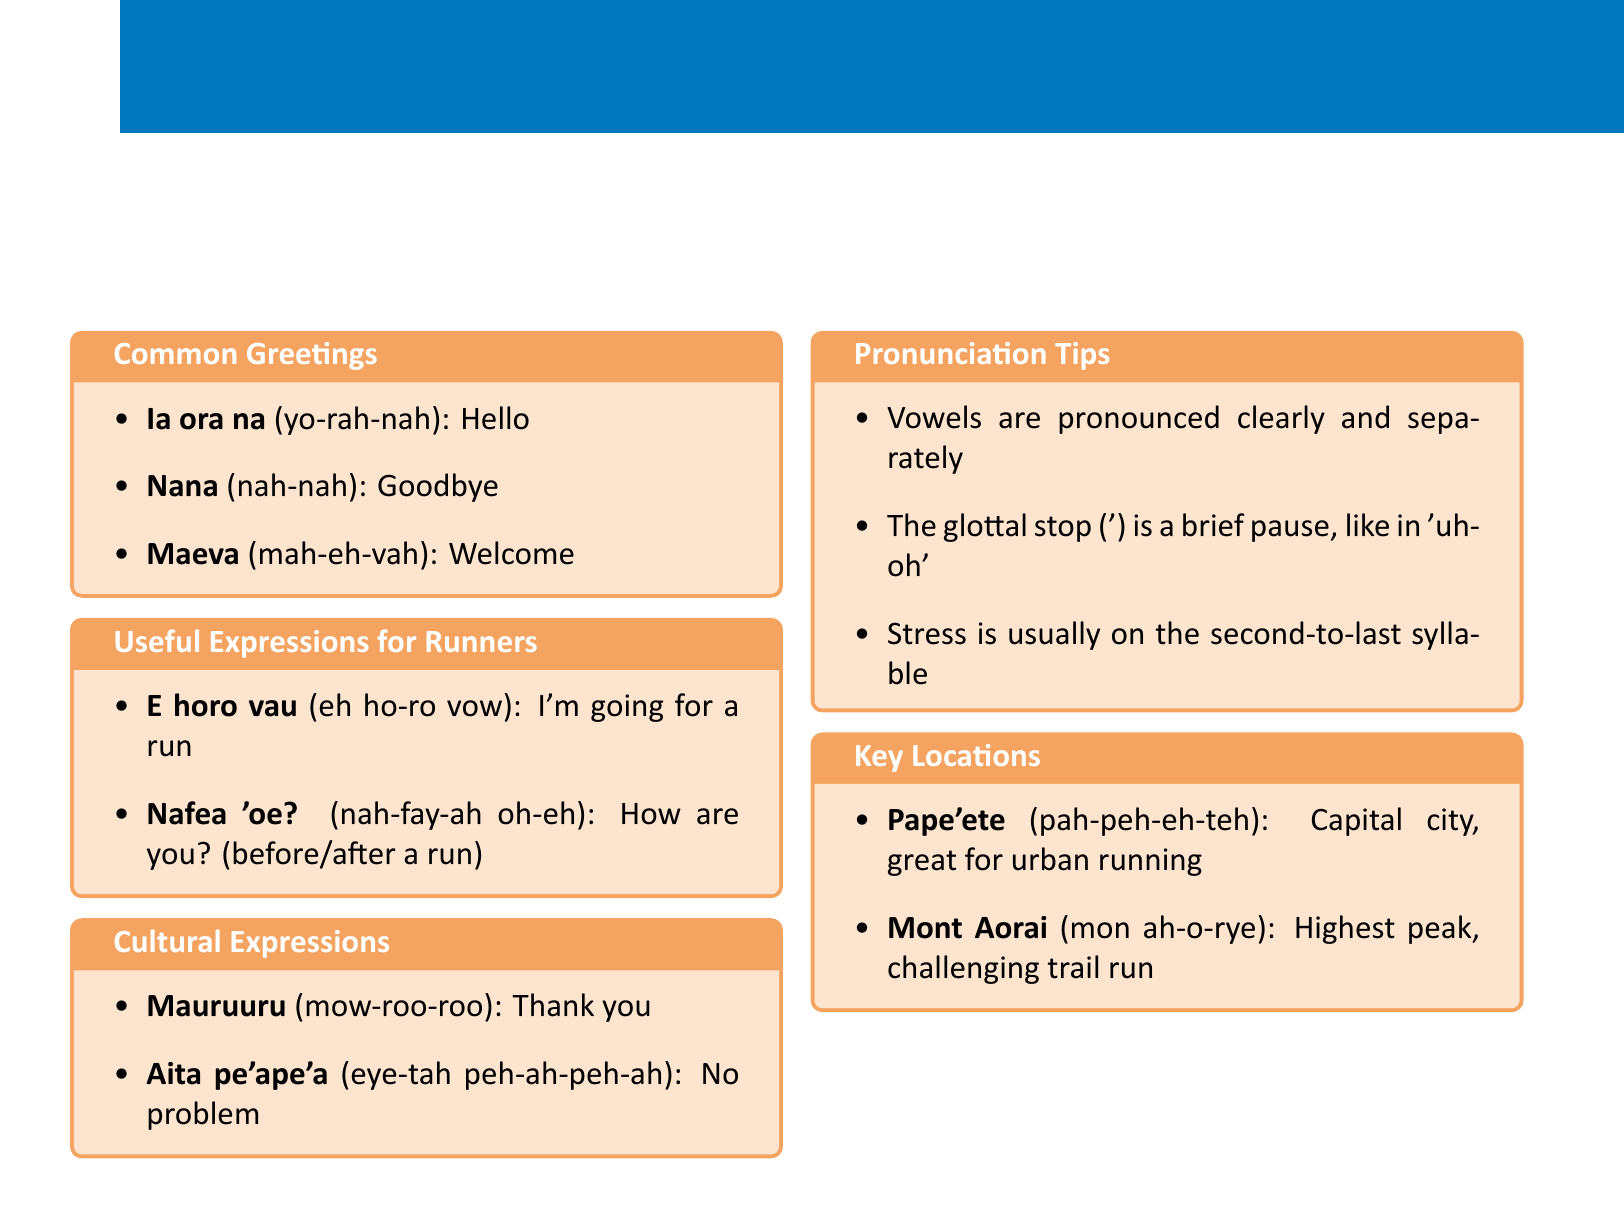What is the Tahitian phrase for "Hello"? The phrase "Ia ora na" translates to "Hello" in English.
Answer: Ia ora na What is the pronunciation of "Nana"? "Nana" is pronounced as "nah-nah".
Answer: nah-nah What does "E horo vau" mean in English? "E horo vau" translates to "I'm going for a run".
Answer: I'm going for a run Which expression means "Thank you"? The phrase "Mauruuru" translates to "Thank you".
Answer: Mauruuru What is the capital city of Tahiti? "Pape'ete" is the capital city and is great for urban running.
Answer: Pape'ete What does the phrase "Aita pe'ape'a" mean? "Aita pe'ape'a" translates to "No problem".
Answer: No problem How should vowels be pronounced in Tahitian? Vowels are pronounced clearly and separately.
Answer: Clearly and separately What is the highest peak mentioned in the document? "Mont Aorai" is the highest peak and offers a challenging trail run.
Answer: Mont Aorai What is typically stressed in Tahitian pronunciation? Stress is usually on the second-to-last syllable.
Answer: Second-to-last syllable 